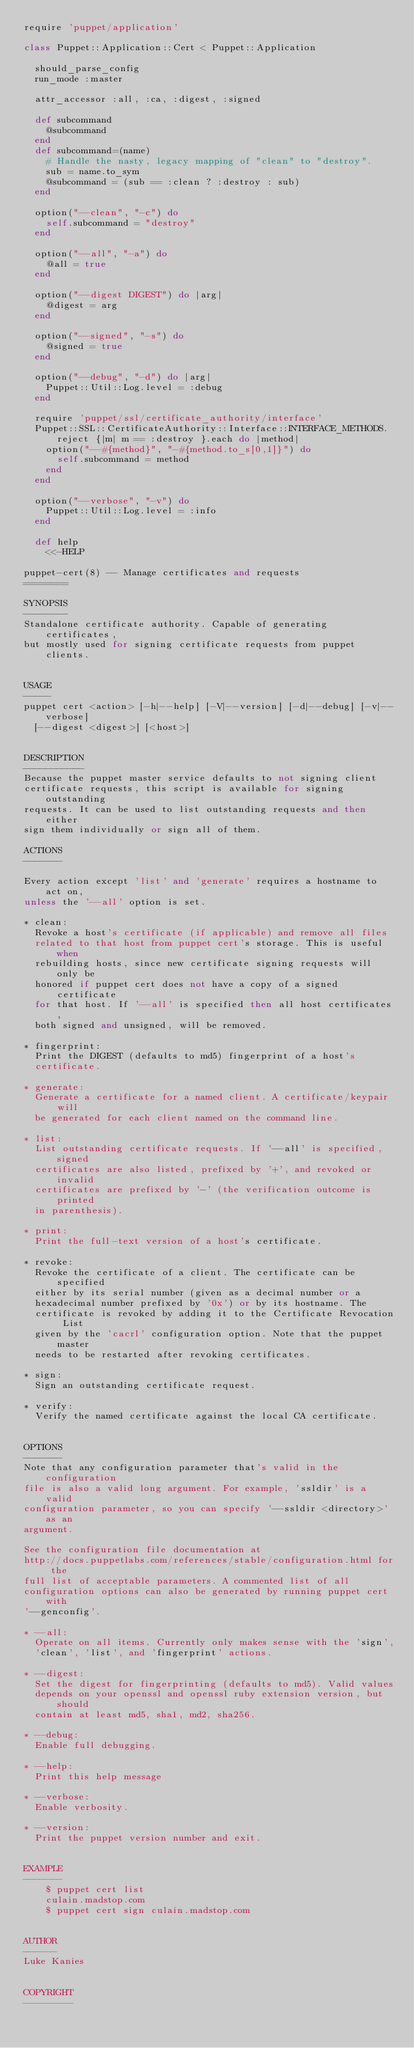Convert code to text. <code><loc_0><loc_0><loc_500><loc_500><_Ruby_>require 'puppet/application'

class Puppet::Application::Cert < Puppet::Application

  should_parse_config
  run_mode :master

  attr_accessor :all, :ca, :digest, :signed

  def subcommand
    @subcommand
  end
  def subcommand=(name)
    # Handle the nasty, legacy mapping of "clean" to "destroy".
    sub = name.to_sym
    @subcommand = (sub == :clean ? :destroy : sub)
  end

  option("--clean", "-c") do
    self.subcommand = "destroy"
  end

  option("--all", "-a") do
    @all = true
  end

  option("--digest DIGEST") do |arg|
    @digest = arg
  end

  option("--signed", "-s") do
    @signed = true
  end

  option("--debug", "-d") do |arg|
    Puppet::Util::Log.level = :debug
  end

  require 'puppet/ssl/certificate_authority/interface'
  Puppet::SSL::CertificateAuthority::Interface::INTERFACE_METHODS.reject {|m| m == :destroy }.each do |method|
    option("--#{method}", "-#{method.to_s[0,1]}") do
      self.subcommand = method
    end
  end

  option("--verbose", "-v") do
    Puppet::Util::Log.level = :info
  end

  def help
    <<-HELP

puppet-cert(8) -- Manage certificates and requests
========

SYNOPSIS
--------
Standalone certificate authority. Capable of generating certificates,
but mostly used for signing certificate requests from puppet clients.


USAGE
-----
puppet cert <action> [-h|--help] [-V|--version] [-d|--debug] [-v|--verbose]
  [--digest <digest>] [<host>]


DESCRIPTION
-----------
Because the puppet master service defaults to not signing client
certificate requests, this script is available for signing outstanding
requests. It can be used to list outstanding requests and then either
sign them individually or sign all of them.

ACTIONS
-------

Every action except 'list' and 'generate' requires a hostname to act on,
unless the '--all' option is set.

* clean:
  Revoke a host's certificate (if applicable) and remove all files
  related to that host from puppet cert's storage. This is useful when
  rebuilding hosts, since new certificate signing requests will only be
  honored if puppet cert does not have a copy of a signed certificate
  for that host. If '--all' is specified then all host certificates,
  both signed and unsigned, will be removed.

* fingerprint:
  Print the DIGEST (defaults to md5) fingerprint of a host's
  certificate.

* generate:
  Generate a certificate for a named client. A certificate/keypair will
  be generated for each client named on the command line.

* list:
  List outstanding certificate requests. If '--all' is specified, signed
  certificates are also listed, prefixed by '+', and revoked or invalid
  certificates are prefixed by '-' (the verification outcome is printed
  in parenthesis).

* print:
  Print the full-text version of a host's certificate.

* revoke:
  Revoke the certificate of a client. The certificate can be specified
  either by its serial number (given as a decimal number or a
  hexadecimal number prefixed by '0x') or by its hostname. The
  certificate is revoked by adding it to the Certificate Revocation List
  given by the 'cacrl' configuration option. Note that the puppet master
  needs to be restarted after revoking certificates.

* sign:
  Sign an outstanding certificate request.

* verify:
  Verify the named certificate against the local CA certificate.


OPTIONS
-------
Note that any configuration parameter that's valid in the configuration
file is also a valid long argument. For example, 'ssldir' is a valid
configuration parameter, so you can specify '--ssldir <directory>' as an
argument.

See the configuration file documentation at
http://docs.puppetlabs.com/references/stable/configuration.html for the
full list of acceptable parameters. A commented list of all
configuration options can also be generated by running puppet cert with
'--genconfig'.

* --all:
  Operate on all items. Currently only makes sense with the 'sign',
  'clean', 'list', and 'fingerprint' actions.

* --digest:
  Set the digest for fingerprinting (defaults to md5). Valid values
  depends on your openssl and openssl ruby extension version, but should
  contain at least md5, sha1, md2, sha256.

* --debug:
  Enable full debugging.

* --help:
  Print this help message

* --verbose:
  Enable verbosity.

* --version:
  Print the puppet version number and exit.


EXAMPLE
-------
    $ puppet cert list
    culain.madstop.com
    $ puppet cert sign culain.madstop.com


AUTHOR
------
Luke Kanies


COPYRIGHT
---------</code> 